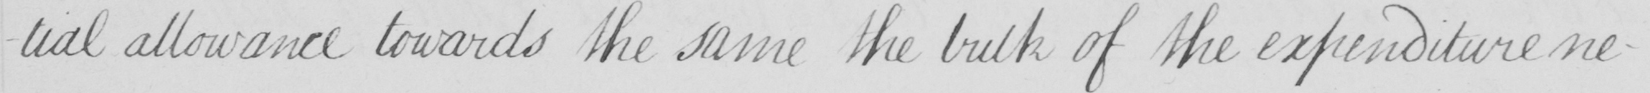Transcribe the text shown in this historical manuscript line. -tial allowance towards the same the bulk of the expenditure ne- 